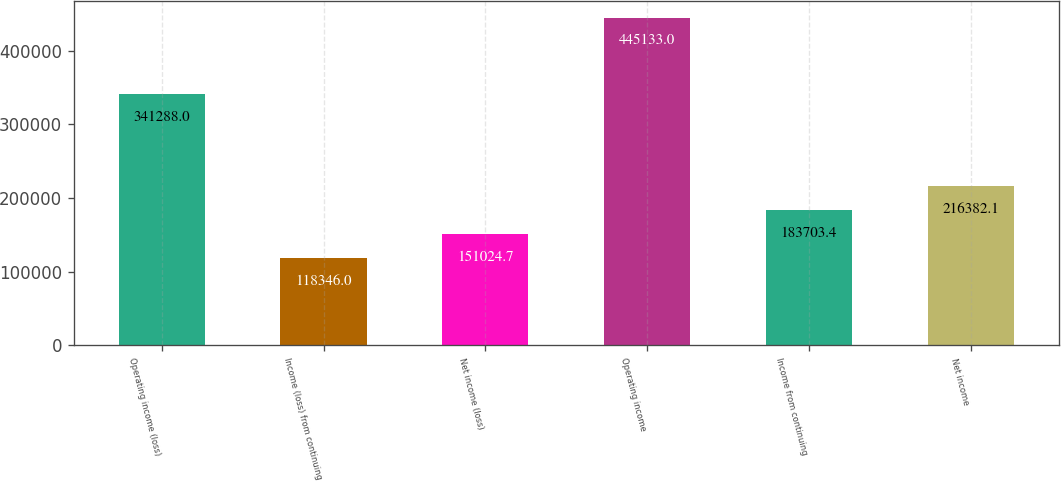Convert chart. <chart><loc_0><loc_0><loc_500><loc_500><bar_chart><fcel>Operating income (loss)<fcel>Income (loss) from continuing<fcel>Net income (loss)<fcel>Operating income<fcel>Income from continuing<fcel>Net income<nl><fcel>341288<fcel>118346<fcel>151025<fcel>445133<fcel>183703<fcel>216382<nl></chart> 